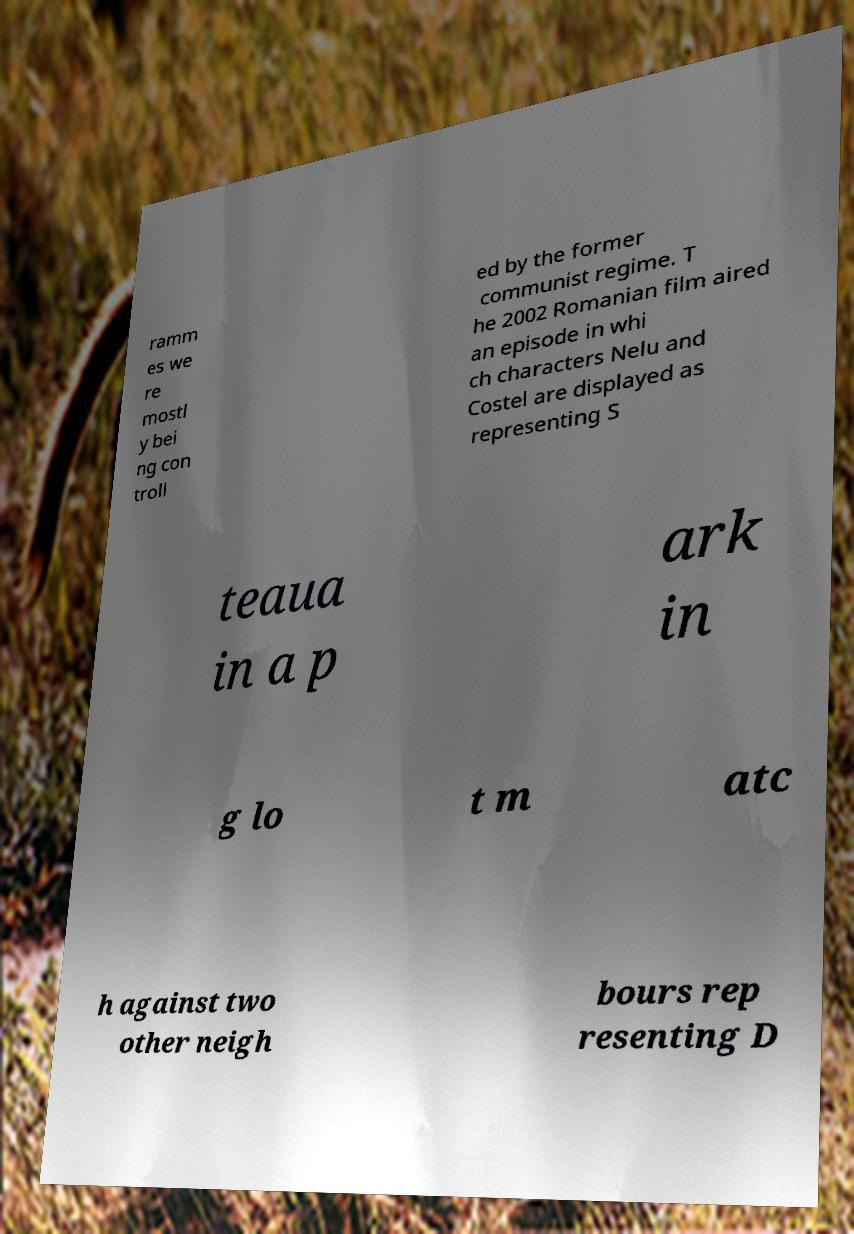Can you read and provide the text displayed in the image?This photo seems to have some interesting text. Can you extract and type it out for me? ramm es we re mostl y bei ng con troll ed by the former communist regime. T he 2002 Romanian film aired an episode in whi ch characters Nelu and Costel are displayed as representing S teaua in a p ark in g lo t m atc h against two other neigh bours rep resenting D 